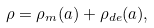<formula> <loc_0><loc_0><loc_500><loc_500>\rho = \rho _ { m } ( a ) + \rho _ { d e } ( a ) ,</formula> 